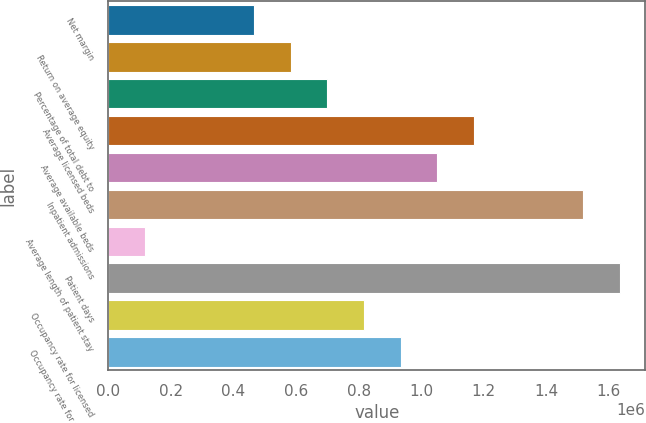Convert chart. <chart><loc_0><loc_0><loc_500><loc_500><bar_chart><fcel>Net margin<fcel>Return on average equity<fcel>Percentage of total debt to<fcel>Average licensed beds<fcel>Average available beds<fcel>Inpatient admissions<fcel>Average length of patient stay<fcel>Patient days<fcel>Occupancy rate for licensed<fcel>Occupancy rate for available<nl><fcel>467091<fcel>583863<fcel>700636<fcel>1.16773e+06<fcel>1.05095e+06<fcel>1.51804e+06<fcel>116773<fcel>1.63482e+06<fcel>817408<fcel>934181<nl></chart> 